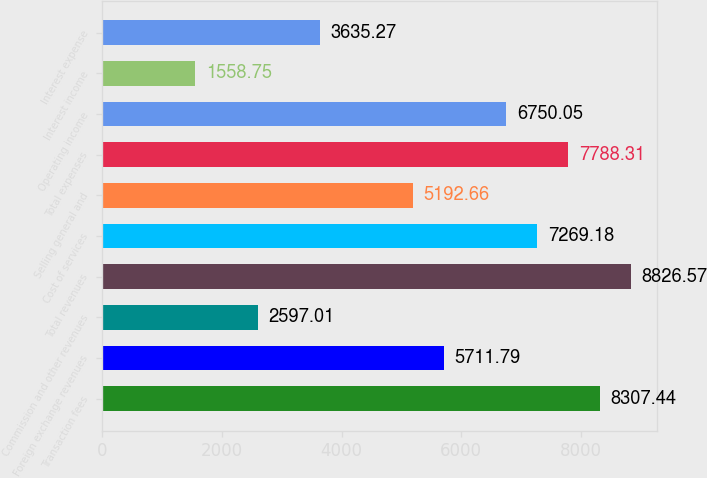Convert chart to OTSL. <chart><loc_0><loc_0><loc_500><loc_500><bar_chart><fcel>Transaction fees<fcel>Foreign exchange revenues<fcel>Commission and other revenues<fcel>Total revenues<fcel>Cost of services<fcel>Selling general and<fcel>Total expenses<fcel>Operating income<fcel>Interest income<fcel>Interest expense<nl><fcel>8307.44<fcel>5711.79<fcel>2597.01<fcel>8826.57<fcel>7269.18<fcel>5192.66<fcel>7788.31<fcel>6750.05<fcel>1558.75<fcel>3635.27<nl></chart> 